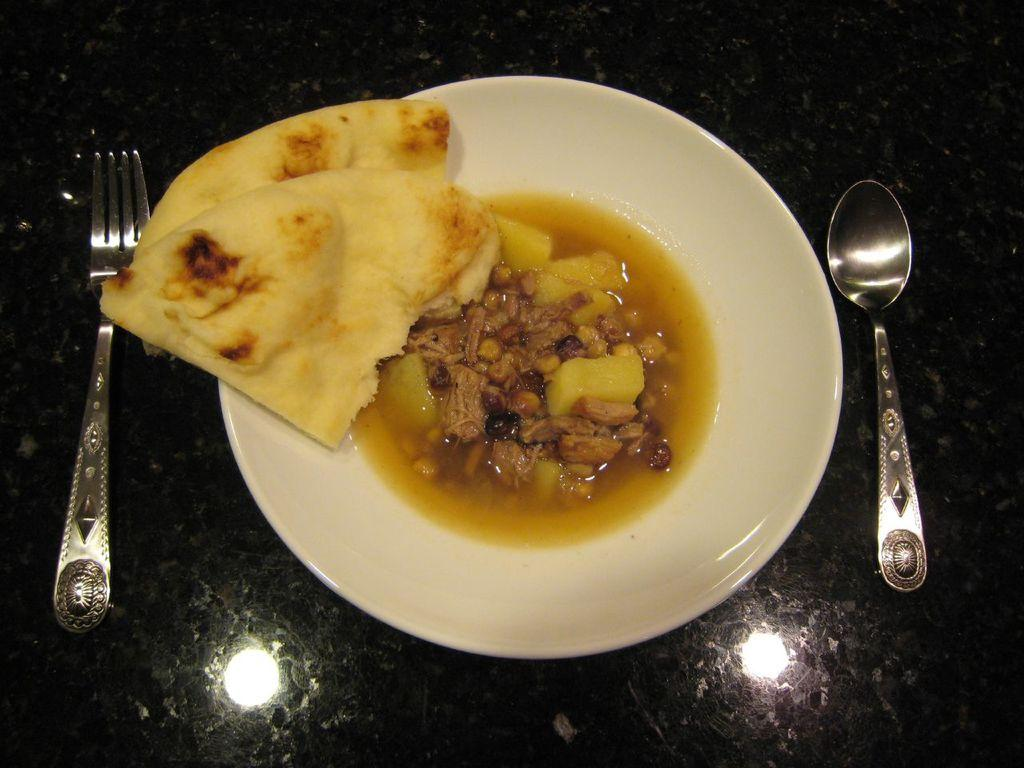What type of food can be seen in the image? The food in the image is in brown and cream colors. How is the food arranged in the image? The food is in a plate. What color is the plate? The plate is white. What utensil is visible in the image? There is a spoon visible in the image. What type of fabric is present in the image? There is a frock on some surface in the image. What type of receipt can be seen in the image? There is no receipt present in the image. What type of amusement is depicted in the image? There is no amusement depicted in the image; it features food in a plate. 